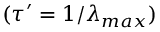Convert formula to latex. <formula><loc_0><loc_0><loc_500><loc_500>( \tau ^ { \prime } = 1 / \lambda _ { \max } )</formula> 